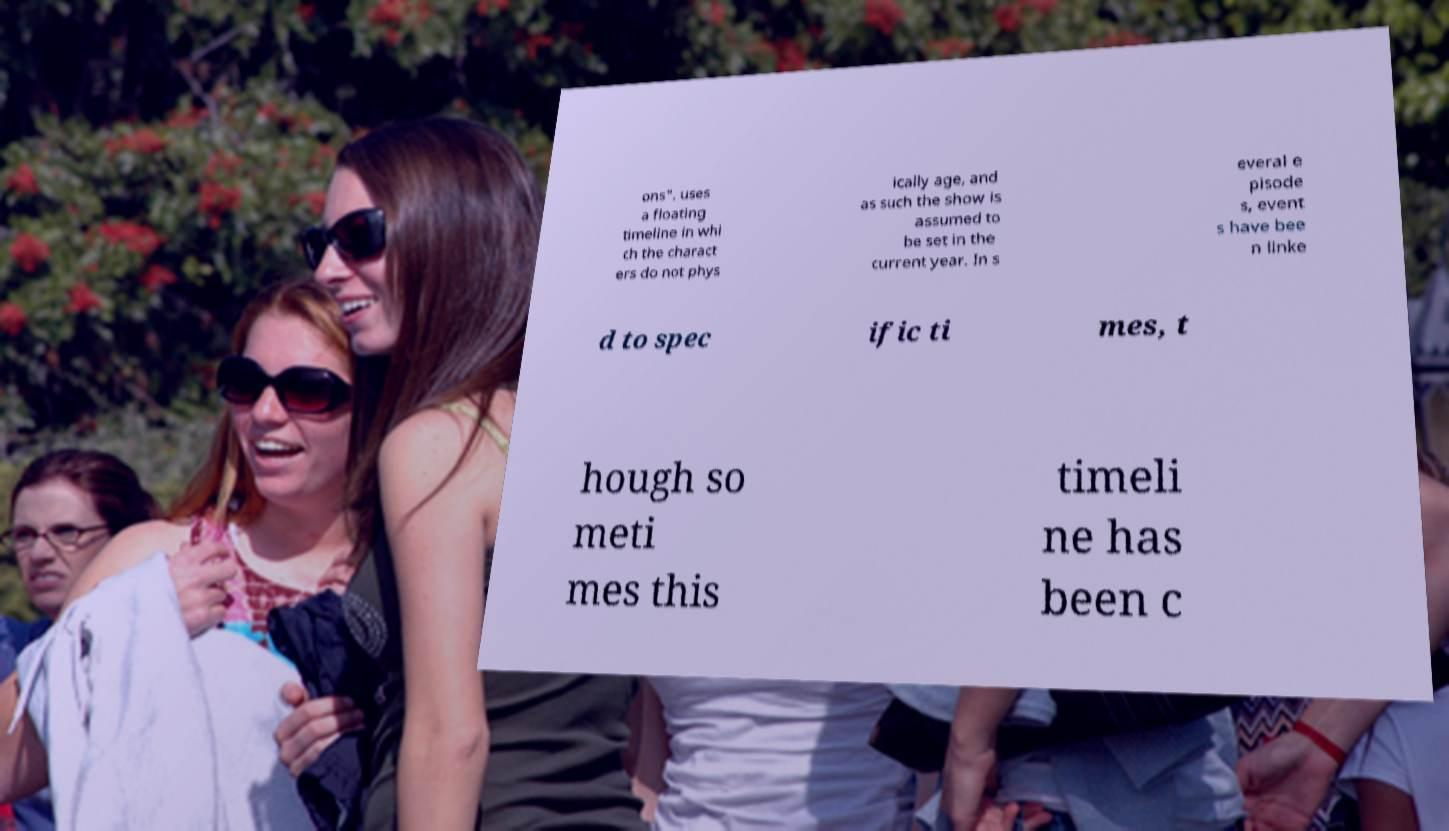Please identify and transcribe the text found in this image. ons". uses a floating timeline in whi ch the charact ers do not phys ically age, and as such the show is assumed to be set in the current year. In s everal e pisode s, event s have bee n linke d to spec ific ti mes, t hough so meti mes this timeli ne has been c 